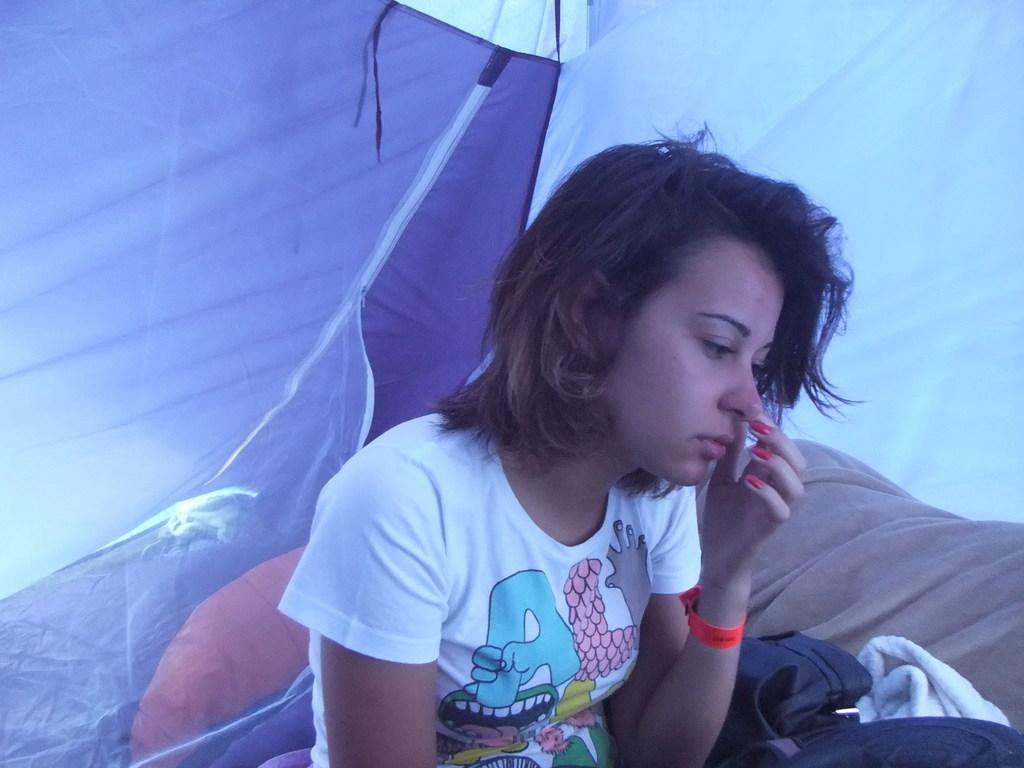What is the lady in the image doing? The lady is sitting in the image. What can be seen on the right side of the image? There are clothes on the right side of the image. What structure is visible in the background of the image? There is a tent visible in the background of the image. What type of liquid is being poured out of the mailbox in the image? There is no mailbox present in the image, and therefore no liquid being poured out of it. 